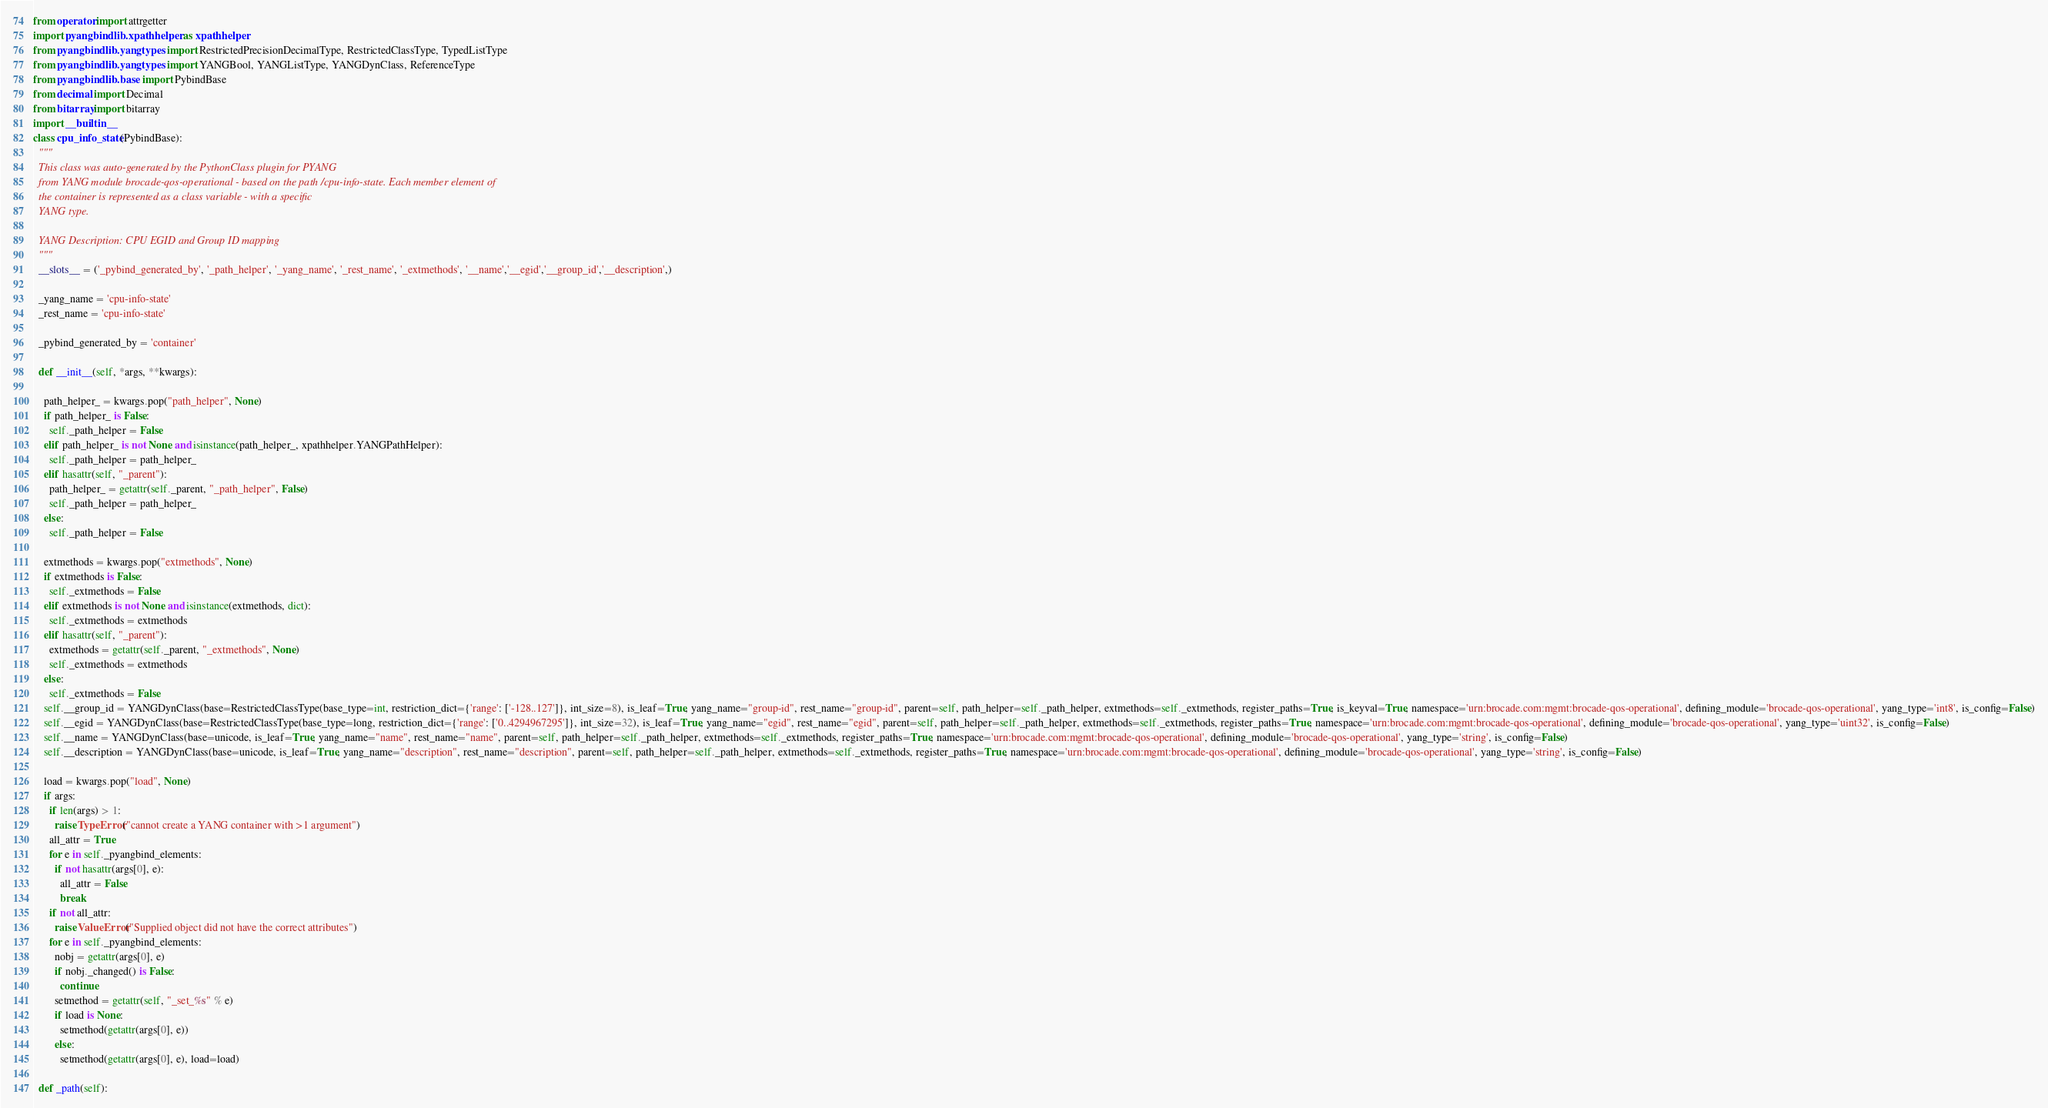Convert code to text. <code><loc_0><loc_0><loc_500><loc_500><_Python_>
from operator import attrgetter
import pyangbind.lib.xpathhelper as xpathhelper
from pyangbind.lib.yangtypes import RestrictedPrecisionDecimalType, RestrictedClassType, TypedListType
from pyangbind.lib.yangtypes import YANGBool, YANGListType, YANGDynClass, ReferenceType
from pyangbind.lib.base import PybindBase
from decimal import Decimal
from bitarray import bitarray
import __builtin__
class cpu_info_state(PybindBase):
  """
  This class was auto-generated by the PythonClass plugin for PYANG
  from YANG module brocade-qos-operational - based on the path /cpu-info-state. Each member element of
  the container is represented as a class variable - with a specific
  YANG type.

  YANG Description: CPU EGID and Group ID mapping
  """
  __slots__ = ('_pybind_generated_by', '_path_helper', '_yang_name', '_rest_name', '_extmethods', '__name','__egid','__group_id','__description',)

  _yang_name = 'cpu-info-state'
  _rest_name = 'cpu-info-state'

  _pybind_generated_by = 'container'

  def __init__(self, *args, **kwargs):

    path_helper_ = kwargs.pop("path_helper", None)
    if path_helper_ is False:
      self._path_helper = False
    elif path_helper_ is not None and isinstance(path_helper_, xpathhelper.YANGPathHelper):
      self._path_helper = path_helper_
    elif hasattr(self, "_parent"):
      path_helper_ = getattr(self._parent, "_path_helper", False)
      self._path_helper = path_helper_
    else:
      self._path_helper = False

    extmethods = kwargs.pop("extmethods", None)
    if extmethods is False:
      self._extmethods = False
    elif extmethods is not None and isinstance(extmethods, dict):
      self._extmethods = extmethods
    elif hasattr(self, "_parent"):
      extmethods = getattr(self._parent, "_extmethods", None)
      self._extmethods = extmethods
    else:
      self._extmethods = False
    self.__group_id = YANGDynClass(base=RestrictedClassType(base_type=int, restriction_dict={'range': ['-128..127']}, int_size=8), is_leaf=True, yang_name="group-id", rest_name="group-id", parent=self, path_helper=self._path_helper, extmethods=self._extmethods, register_paths=True, is_keyval=True, namespace='urn:brocade.com:mgmt:brocade-qos-operational', defining_module='brocade-qos-operational', yang_type='int8', is_config=False)
    self.__egid = YANGDynClass(base=RestrictedClassType(base_type=long, restriction_dict={'range': ['0..4294967295']}, int_size=32), is_leaf=True, yang_name="egid", rest_name="egid", parent=self, path_helper=self._path_helper, extmethods=self._extmethods, register_paths=True, namespace='urn:brocade.com:mgmt:brocade-qos-operational', defining_module='brocade-qos-operational', yang_type='uint32', is_config=False)
    self.__name = YANGDynClass(base=unicode, is_leaf=True, yang_name="name", rest_name="name", parent=self, path_helper=self._path_helper, extmethods=self._extmethods, register_paths=True, namespace='urn:brocade.com:mgmt:brocade-qos-operational', defining_module='brocade-qos-operational', yang_type='string', is_config=False)
    self.__description = YANGDynClass(base=unicode, is_leaf=True, yang_name="description", rest_name="description", parent=self, path_helper=self._path_helper, extmethods=self._extmethods, register_paths=True, namespace='urn:brocade.com:mgmt:brocade-qos-operational', defining_module='brocade-qos-operational', yang_type='string', is_config=False)

    load = kwargs.pop("load", None)
    if args:
      if len(args) > 1:
        raise TypeError("cannot create a YANG container with >1 argument")
      all_attr = True
      for e in self._pyangbind_elements:
        if not hasattr(args[0], e):
          all_attr = False
          break
      if not all_attr:
        raise ValueError("Supplied object did not have the correct attributes")
      for e in self._pyangbind_elements:
        nobj = getattr(args[0], e)
        if nobj._changed() is False:
          continue
        setmethod = getattr(self, "_set_%s" % e)
        if load is None:
          setmethod(getattr(args[0], e))
        else:
          setmethod(getattr(args[0], e), load=load)

  def _path(self):</code> 